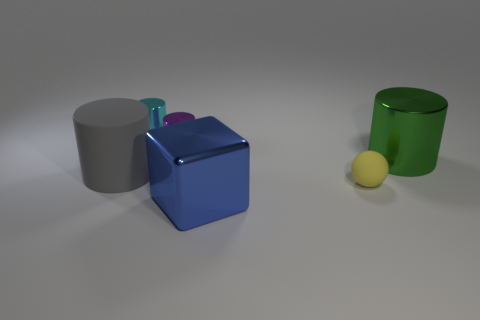How many metal objects are either large blue blocks or small purple cylinders? In the image, there is one large blue block and one small purple cylinder that appear to be metal, making a total of 2 metal objects that fit the criteria. 